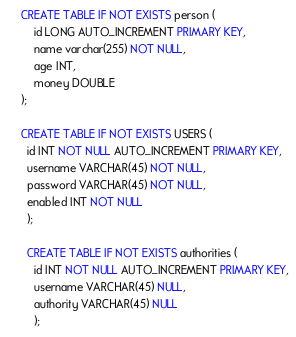Convert code to text. <code><loc_0><loc_0><loc_500><loc_500><_SQL_>CREATE TABLE IF NOT EXISTS person (
    id LONG AUTO_INCREMENT PRIMARY KEY,
    name varchar(255) NOT NULL,
    age INT,
    money DOUBLE
);

CREATE TABLE IF NOT EXISTS USERS (
  id INT NOT NULL AUTO_INCREMENT PRIMARY KEY,
  username VARCHAR(45) NOT NULL,
  password VARCHAR(45) NOT NULL,
  enabled INT NOT NULL
  );

  CREATE TABLE IF NOT EXISTS authorities (
    id INT NOT NULL AUTO_INCREMENT PRIMARY KEY,
    username VARCHAR(45) NULL,
    authority VARCHAR(45) NULL
    );</code> 